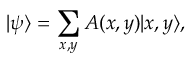<formula> <loc_0><loc_0><loc_500><loc_500>| \psi \rangle = \sum _ { x , y } A ( x , y ) | x , y \rangle ,</formula> 